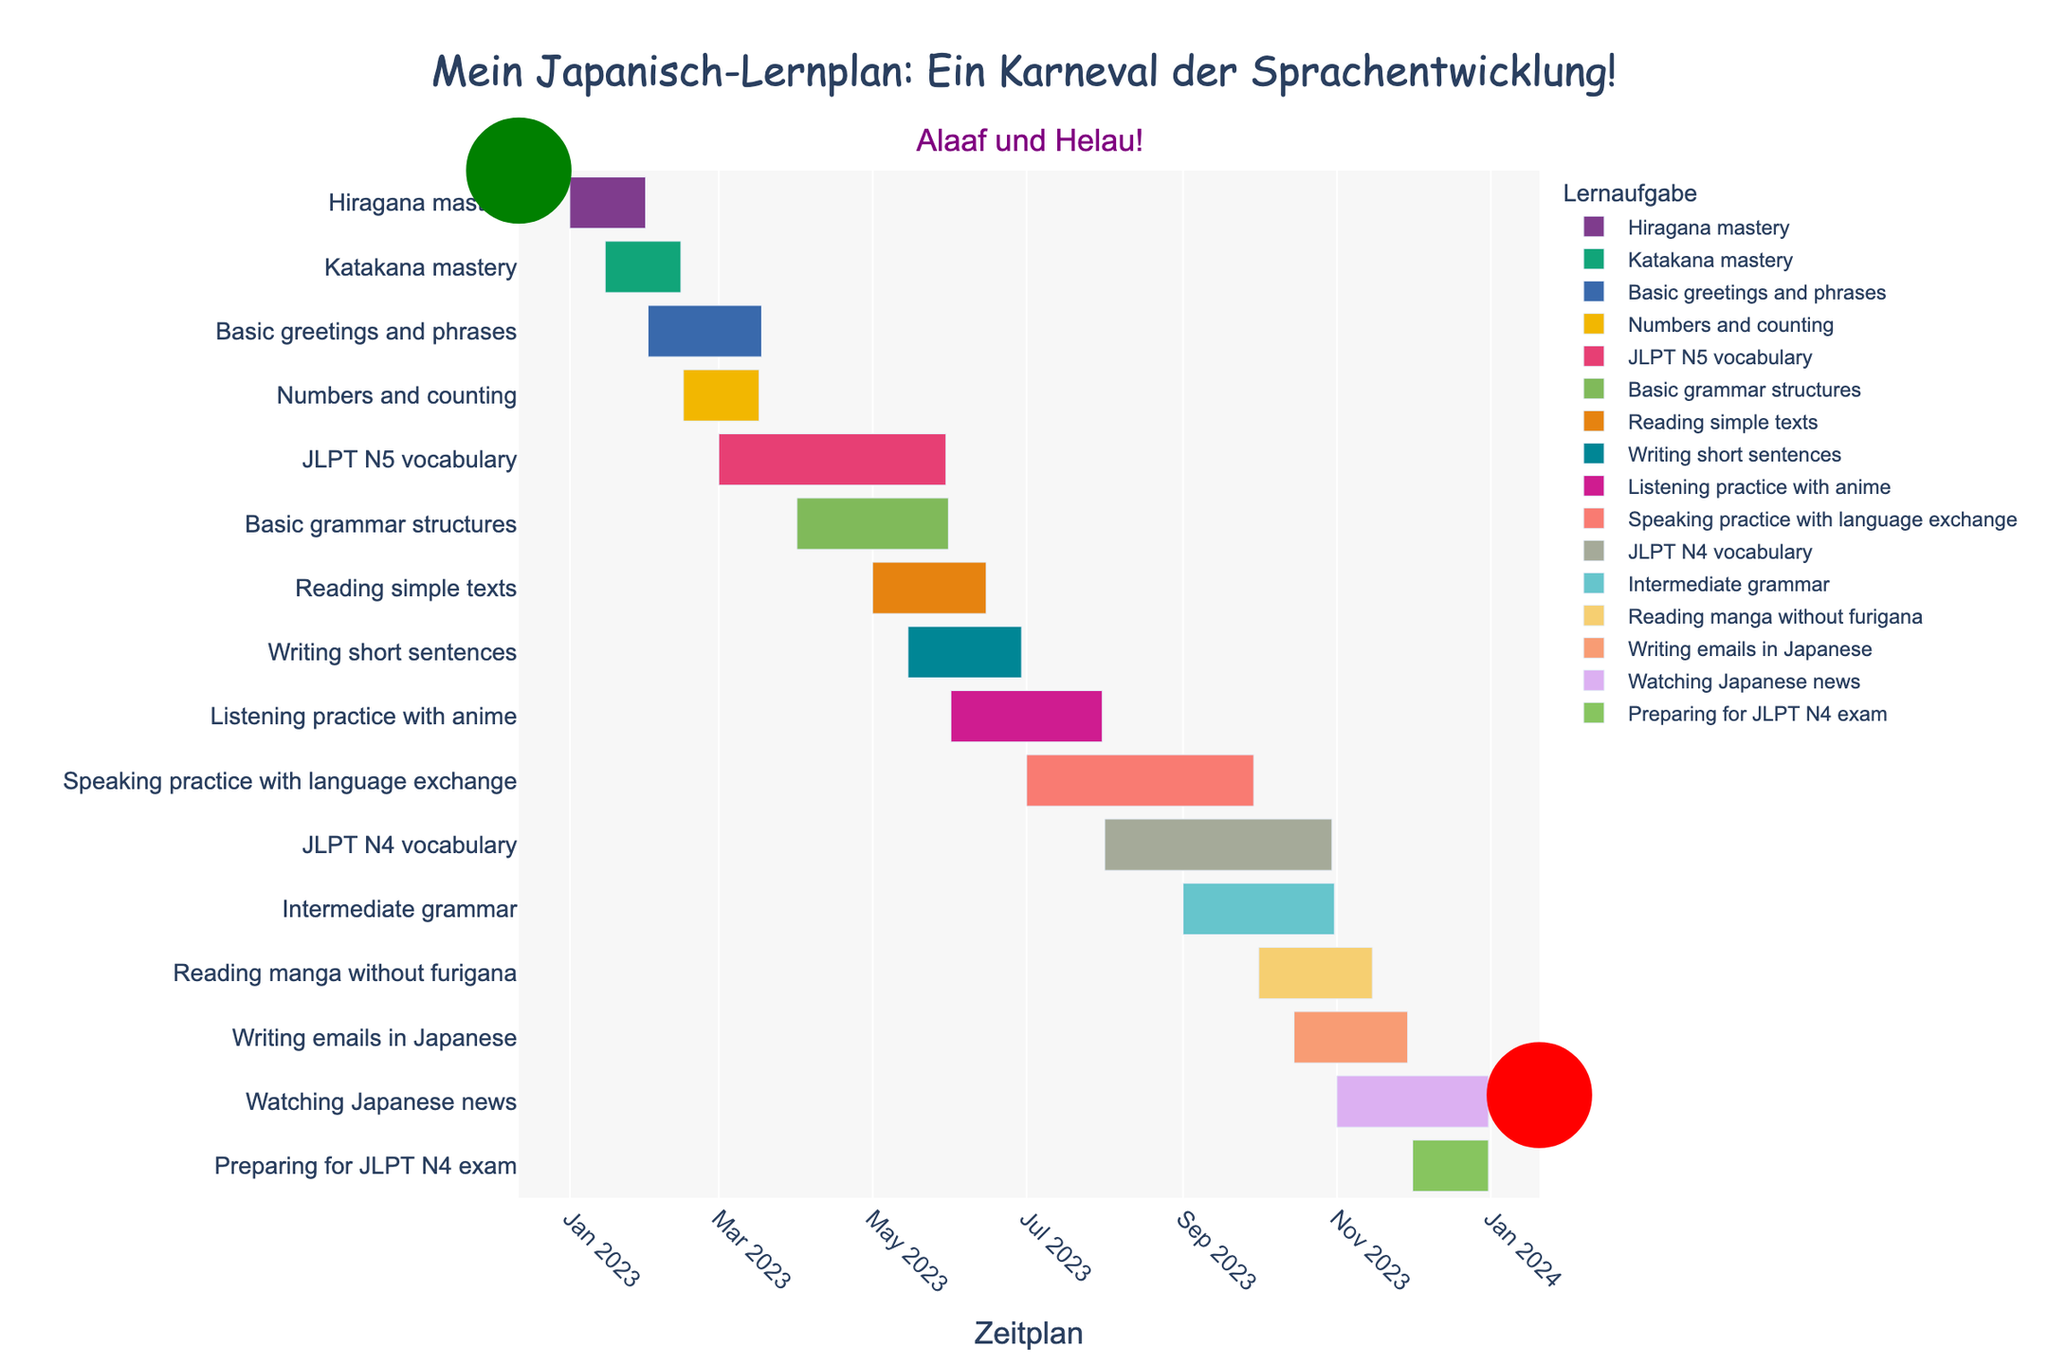What is the title of the Gantt chart? The title of the Gantt chart is displayed prominently at the top center of the figure. It reads "Mein Japanisch-Lernplan: Ein Karneval der Sprachentwicklung!"
Answer: Mein Japanisch-Lernplan: Ein Karneval der Sprachentwicklung! What is the duration of the "Katakana mastery" task? The duration of the "Katakana mastery" task is indicated by the length of the bar corresponding to this task. The duration listed is 30 days.
Answer: 30 days Which task ends first, "Hiragana mastery" or "Basic greetings and phrases"? To determine which task ends first, look at the end dates of the tasks "Hiragana mastery" and "Basic greetings and phrases". "Hiragana mastery" starts on January 1st and lasts 30 days, ending on January 30th. "Basic greetings and phrases" starts on February 1st and lasts 45 days, ending on March 18th. Therefore, "Hiragana mastery" ends first.
Answer: Hiragana mastery How long is the overlap between "Hiragana mastery" and "Katakana mastery"? First, note that "Hiragana mastery" starts on January 1st and lasts 30 days (ends January 30th). "Katakana mastery" starts on January 15th and also lasts 30 days (ends February 14th). The overlapping period is from January 15th to January 30th. This gives an overlap of 16 days (inclusive of both start and end dates).
Answer: 16 days Which tasks are scheduled to start in May? Tasks scheduled to start in May are visually represented by the bars starting within that timeframe on the Gantt chart. From the chart, "Reading simple texts" starts on May 1st and "Writing short sentences" starts on May 15th.
Answer: Reading simple texts and Writing short sentences What is the total duration for "JLPT N5 vocabulary" and "JLPT N4 vocabulary"? The total duration can be calculated by summing the durations of "JLPT N5 vocabulary" and "JLPT N4 vocabulary". "JLPT N5 vocabulary" lasts for 90 days and "JLPT N4 vocabulary" also lasts for 90 days. The total duration is 90 + 90 = 180 days.
Answer: 180 days Which task has the longest duration, and what is its duration? The task with the longest duration can be identified by looking for the longest bar on the Gantt chart. "Speaking practice with language exchange" and "JLPT N4 vocabulary" both have the longest bar, each lasting 90 days.
Answer: Speaking practice with language exchange and JLPT N4 vocabulary, 90 days Is there any task that spans across three months? If so, which one? Look for tasks whose bars cover parts of three consecutive months. "JLPT N5 vocabulary" begins on March 1st and ends on May 30th, covering March, April, and May. Similarly, "Speaking practice with language exchange" begins July 1st to September 28th covering July, August, and September., and "JLPT N4 vocabulary" begins August 1st and ends on October 29th. Hence, all three span three months.
Answer: JLPT N5 vocabulary, Speaking practice with language exchange, JLPT N4 vocabulary How many tasks start in 2023 but do not end in the same year? To determine this, check the Gantt chart for tasks that start in 2023 but whose end dates extend into 2024. From the chart, none of the tasks have end dates extending into 2024. All tasks end within 2023.
Answer: None 